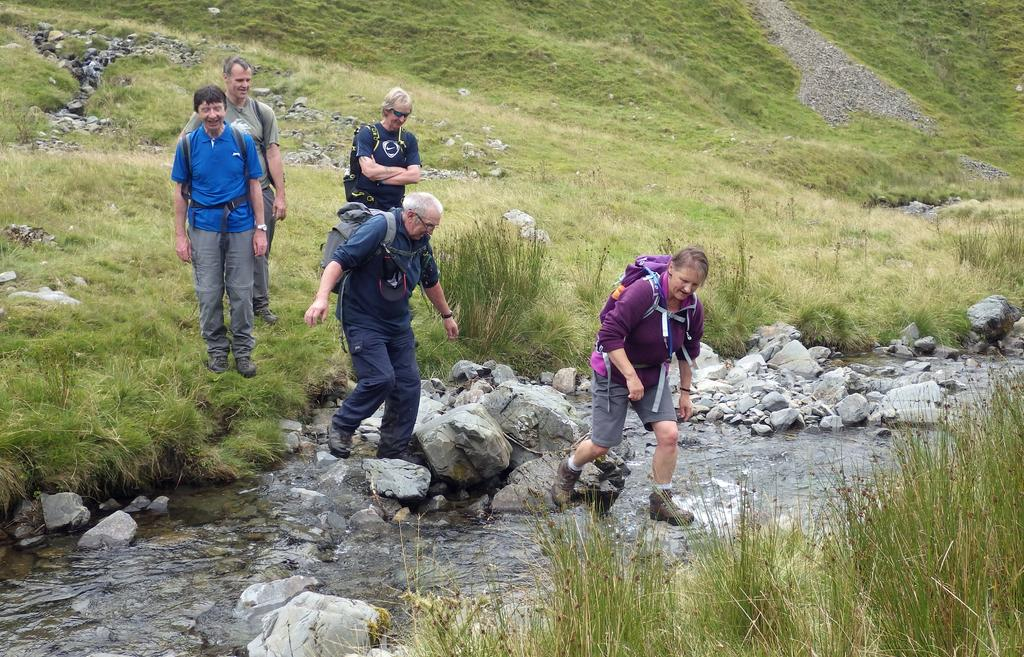What are the people in the image wearing on their bodies? The people in the image are wearing bags. What is the ground made of in the image? The ground is made of green grass and there are stones on it. What can be seen in the stream in the image? There are rocks in the stream. What are the two persons doing in the image? The two persons are crossing the stream. How many knees can be seen in the image? There is no specific mention of knees in the image, so it is not possible to determine the number of knees visible. 